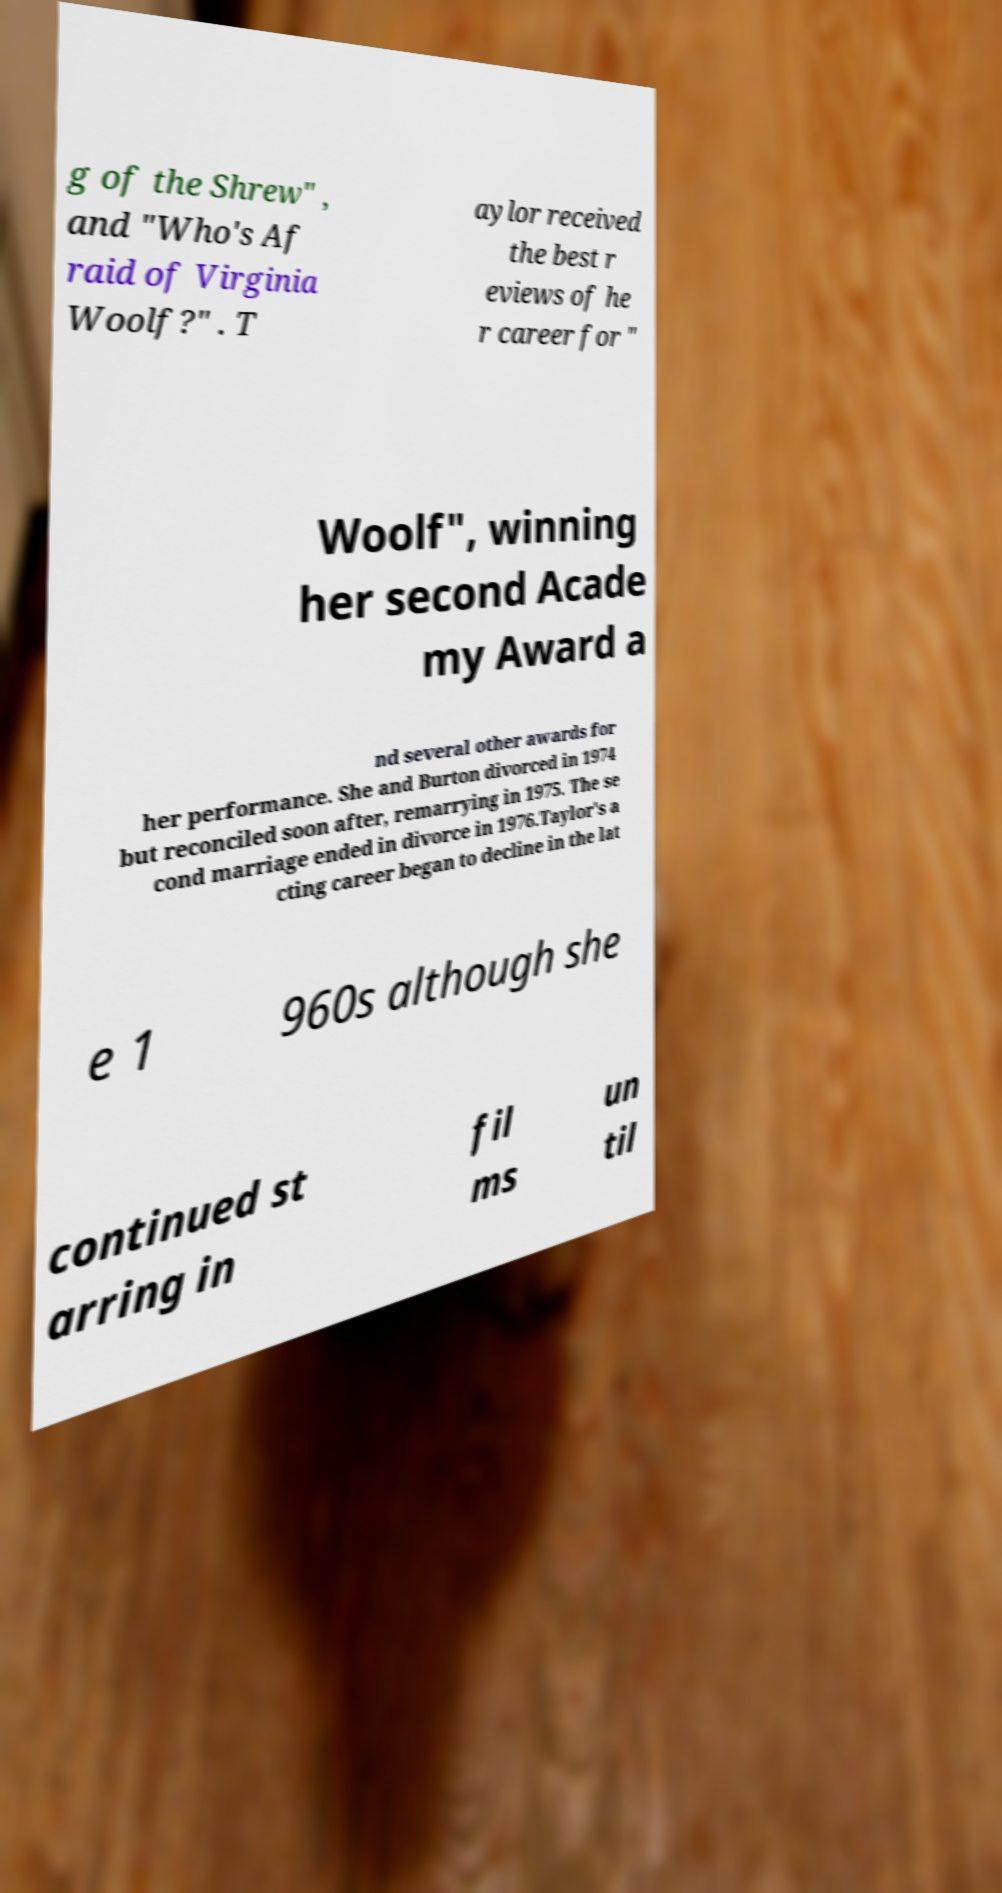Please identify and transcribe the text found in this image. g of the Shrew" , and "Who's Af raid of Virginia Woolf?" . T aylor received the best r eviews of he r career for " Woolf", winning her second Acade my Award a nd several other awards for her performance. She and Burton divorced in 1974 but reconciled soon after, remarrying in 1975. The se cond marriage ended in divorce in 1976.Taylor's a cting career began to decline in the lat e 1 960s although she continued st arring in fil ms un til 